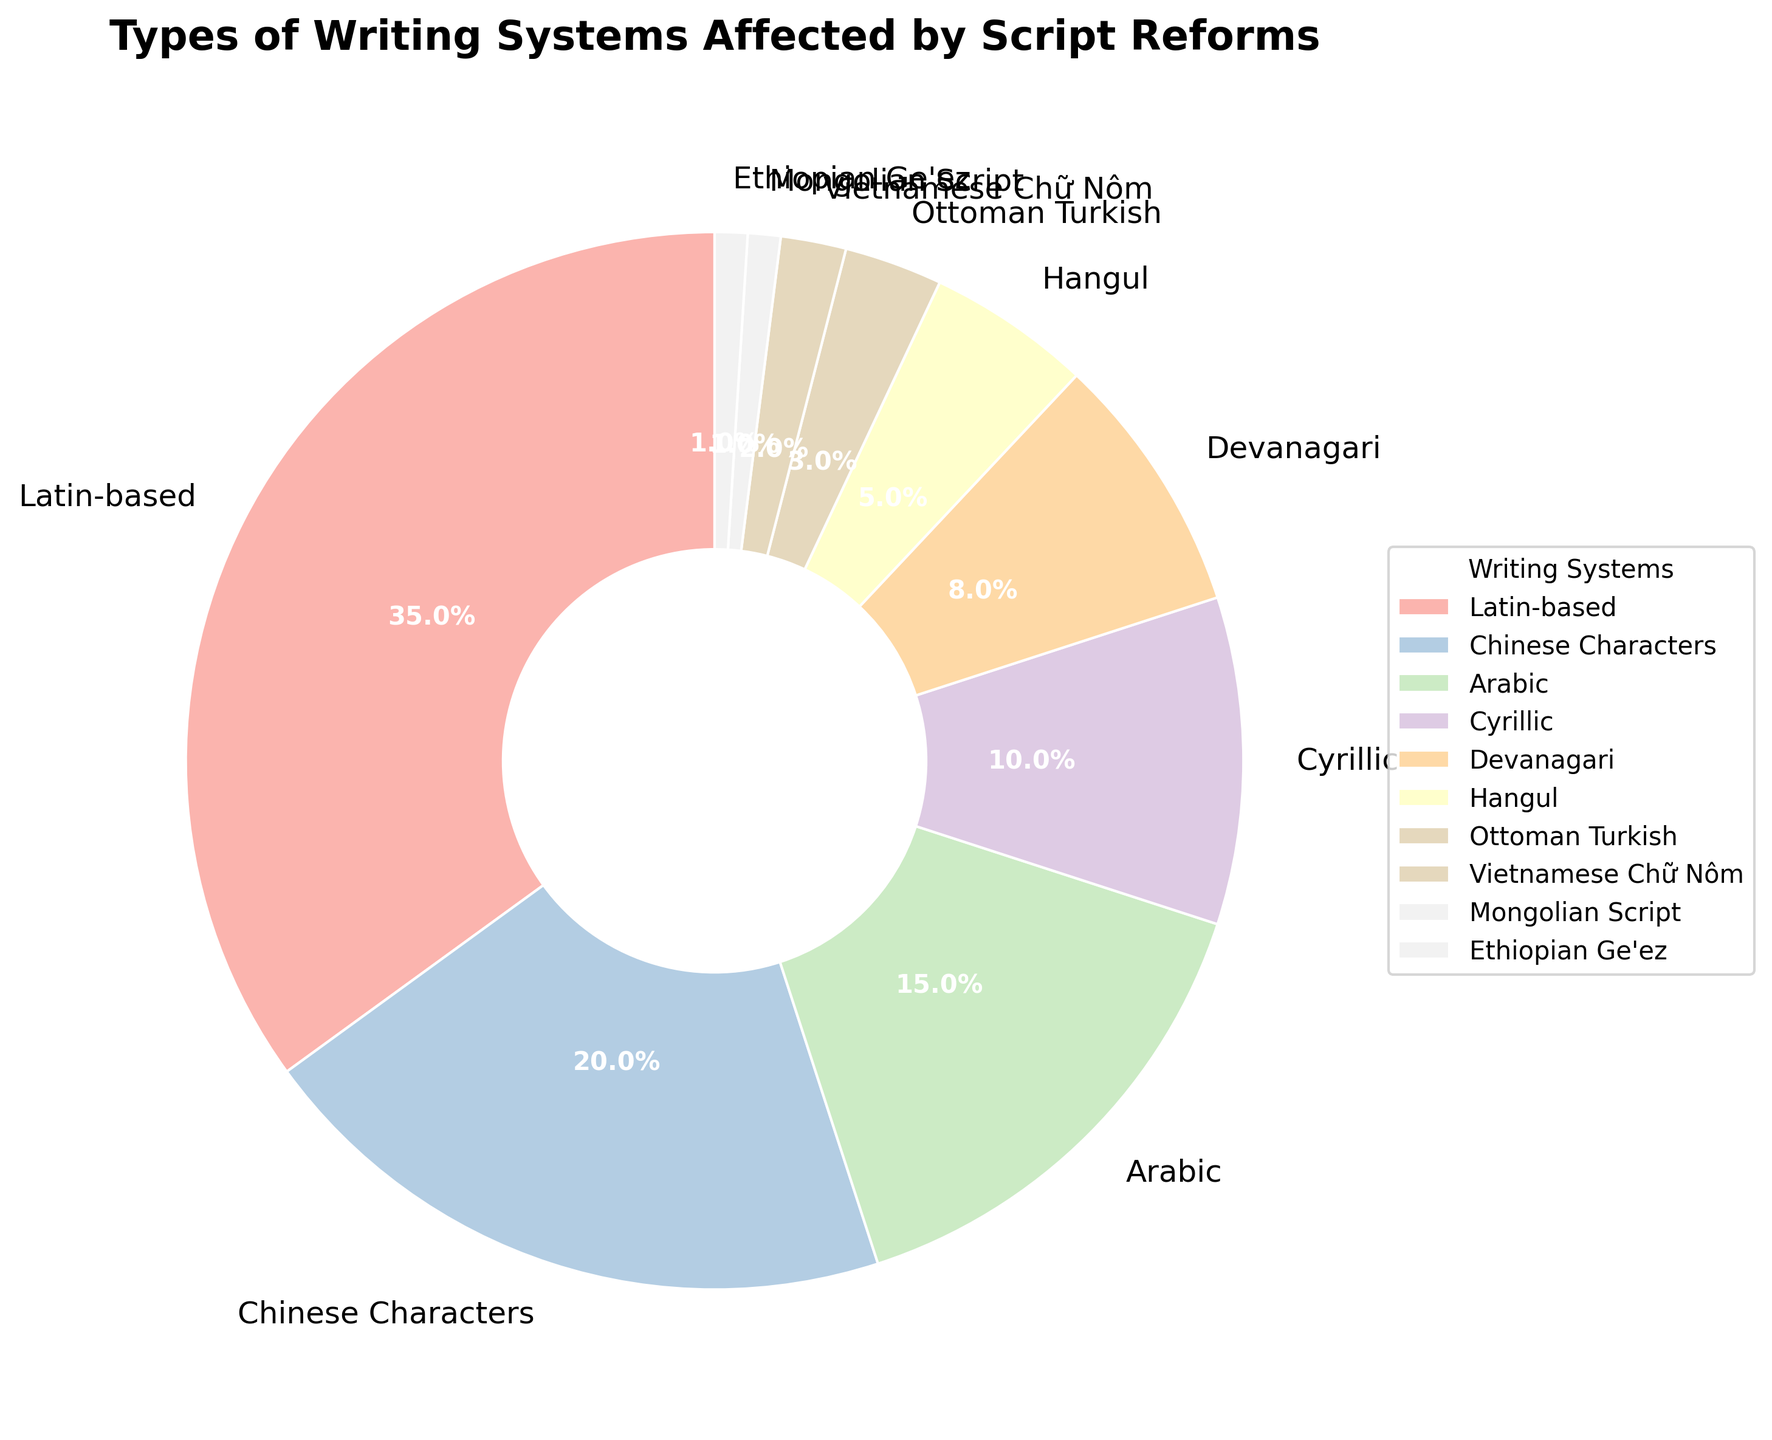Which writing system has the largest percentage affected by script reforms? The writing system with the largest percentage in the pie chart is Latin-based, occupying the largest segment.
Answer: Latin-based What is the total percentage of writing systems affected by script reforms that have a percentage of 5% or less? Sum the percentages of Hangul (5%), Ottoman Turkish (3%), Vietnamese Chữ Nôm (2%), Mongolian Script (1%), and Ethiopian Ge'ez (1%): 5 + 3 + 2 + 1 + 1 = 12%.
Answer: 12% How much larger is the percentage of Latin-based systems compared to Arabic systems? Subtract the percentage of Arabic (15%) from the percentage of Latin-based (35%): 35 - 15 = 20%.
Answer: 20% Which writing systems individually account for less than 10% of the total affected by script reforms? The writing systems with percentages less than 10% are Devanagari (8%), Hangul (5%), Ottoman Turkish (3%), Vietnamese Chữ Nôm (2%), Mongolian Script (1%), and Ethiopian Ge'ez (1%).
Answer: Devanagari, Hangul, Ottoman Turkish, Vietnamese Chữ Nôm, Mongolian Script, Ethiopian Ge'ez Are Chinese characters more affected by script reforms than Cyrillic? Compare the percentages: Chinese Characters (20%) are more affected than Cyrillic (10%).
Answer: Yes What is the sum of the percentages for Arabic and Chinese Characters combined? Add the percentages for Arabic (15%) and Chinese Characters (20%): 15 + 20 = 35%.
Answer: 35% If you combine the percentages of Devanagari, Hangul, and Ottoman Turkish, does it exceed the percentage of Arabic systems? Sum the percentages of Devanagari (8%), Hangul (5%), and Ottoman Turkish (3%): 8 + 5 + 3 = 16%. Compare this with Arabic which is 15%.
Answer: Yes What percentage of the total do non-Latin-based systems account for? Subtract the percentage of Latin-based (35%) from 100%: 100 - 35 = 65%.
Answer: 65% Among the writing systems listed, which two have the smallest percentages affected by script reforms? Identify the two writing systems with the smallest percentages: Mongolian Script and Ethiopian Ge'ez both have 1%.
Answer: Mongolian Script, Ethiopian Ge'ez 